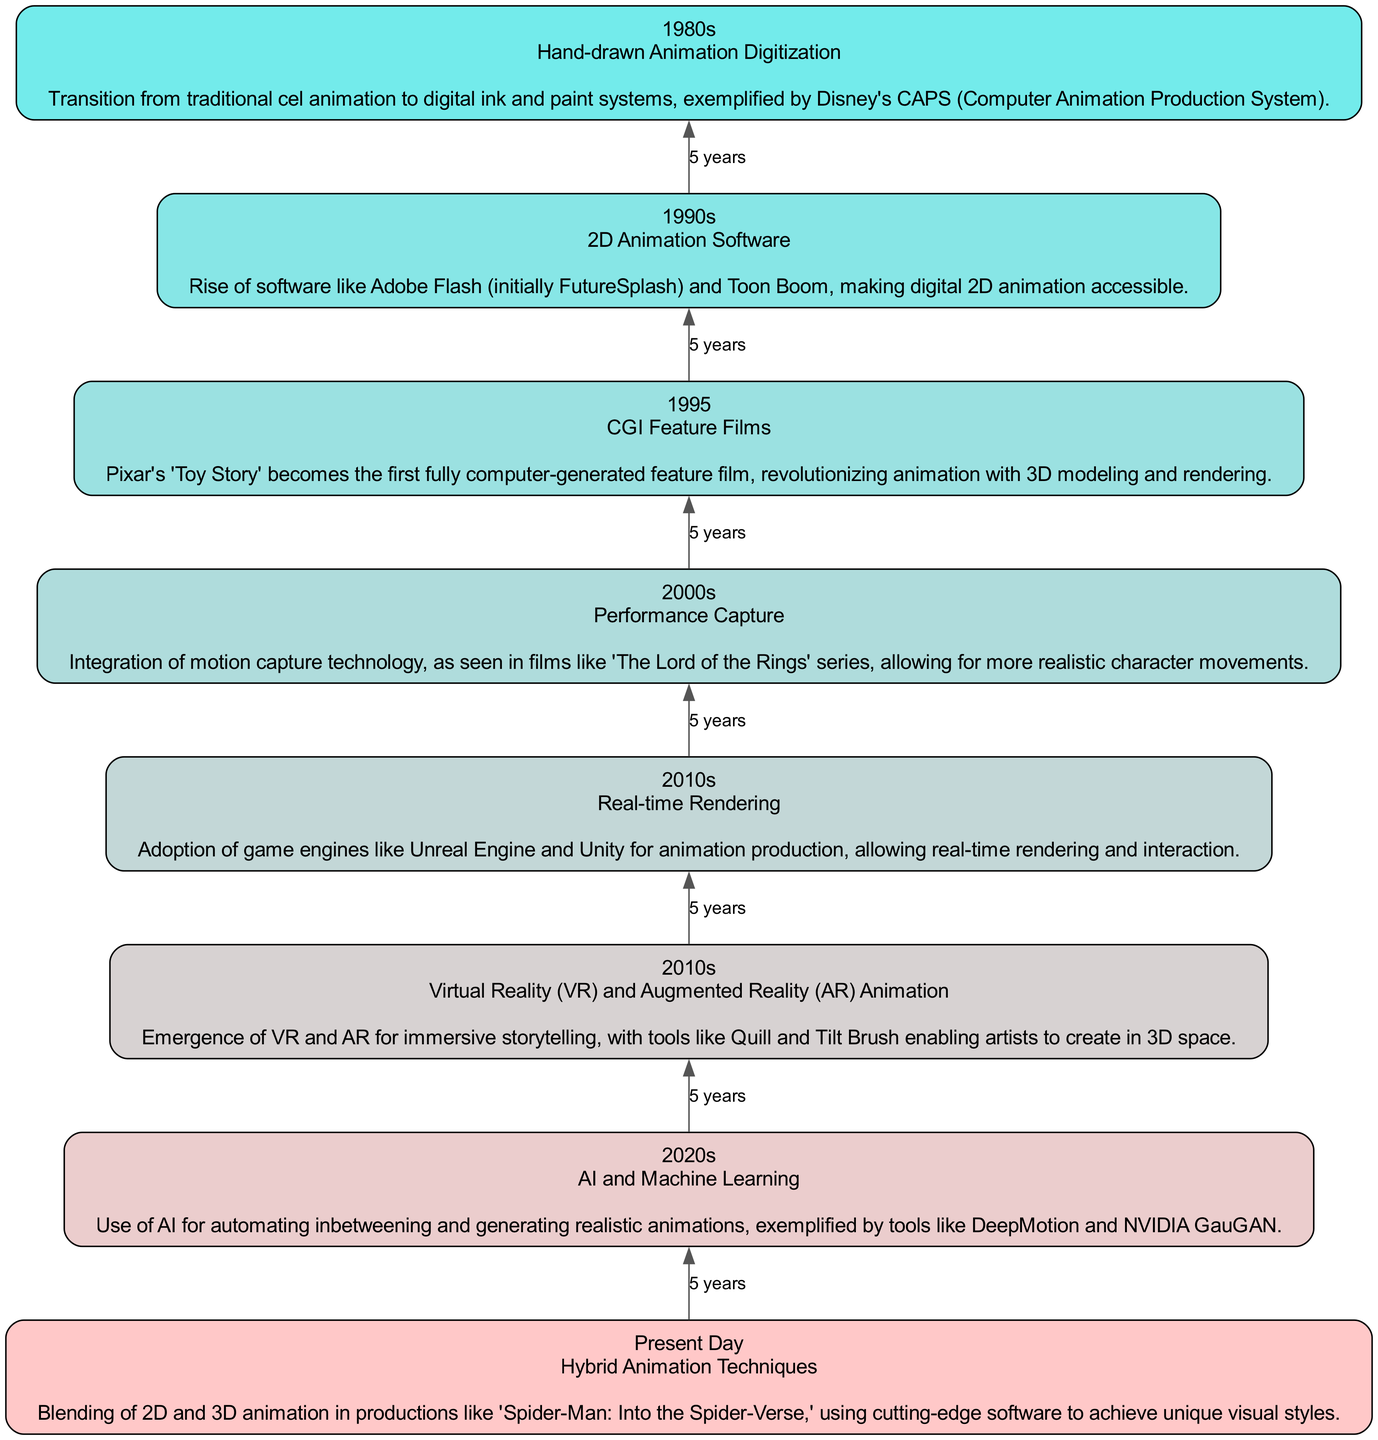What animation technology was introduced in the 1980s? The diagram indicates that in the 1980s, the technology introduced was "Hand-drawn Animation Digitization." This is listed directly under the '1980s' node.
Answer: Hand-drawn Animation Digitization How many technologies are listed in the diagram? By counting the nodes in the diagram from the 1980s to Present Day, there are a total of 8 distinct technologies mentioned.
Answer: 8 What was the significance of the technology introduced in 1995? The node for 1995 states that "Pixar's 'Toy Story' becomes the first fully computer-generated feature film," which revolutionized animation with 3D modeling and rendering. This indicates its importance in establishing CGI in mainstream animation.
Answer: First fully computer-generated feature film What technology allows for more realistic character movements in the 2000s? The diagram indicates that "Performance Capture" technology was introduced in the 2000s, enabling more realistic character movements, particularly highlighted by its use in 'The Lord of the Rings' series.
Answer: Performance Capture Which technology followed the introduction of AI and Machine Learning in the 2020s? After "AI and Machine Learning," the next technology listed in the timeline is "Hybrid Animation Techniques." This can be determined by following the flow upward and observing the subsequent node.
Answer: Hybrid Animation Techniques How did the animation technologies progress from the 1980s to Present Day? Examining the timeline from the bottom to the top, it shows a progression from "Hand-drawn Animation Digitization" to "Hybrid Animation Techniques." This indicates a clear advancement in digital animation capabilities over the decades.
Answer: From 2D to hybrid techniques What is the main focus of animation in the 2010s according to the chart? The diagram highlights two technologies in the 2010s: "Real-time Rendering" and "Virtual Reality (VR) and Augmented Reality (AR) Animation." This shows a focus on immersive and interactive animation techniques during this decade.
Answer: Real-time Rendering and VR/AR Animation How long did it take to transition from 1980s to 1995 in terms of animation technology? The diagram timeline shows a period of 15 years from 1980s to 1995, marking a significant development phase, particularly for advanced CGI films like "Toy Story."
Answer: 15 years What animation technology is mentioned for immersive storytelling? The diagram specifies "Virtual Reality (VR) and Augmented Reality (AR) Animation" as the technology that facilitates immersive storytelling, indicating its rise in the 2010s section of the flow.
Answer: Virtual Reality and Augmented Reality Animation 